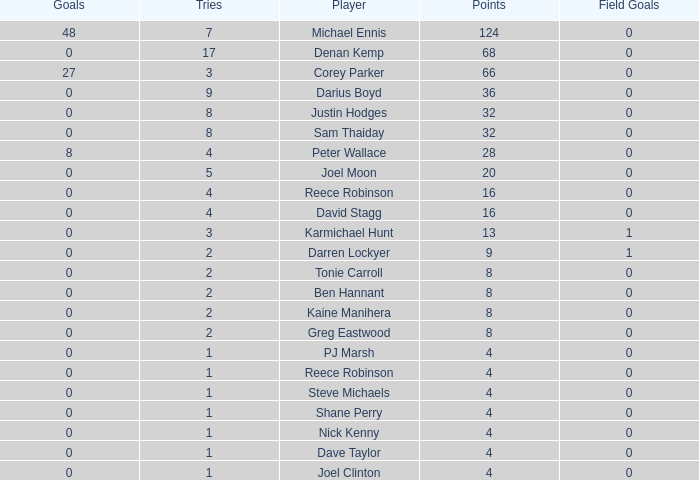How many goals did the player with less than 4 points have? 0.0. 